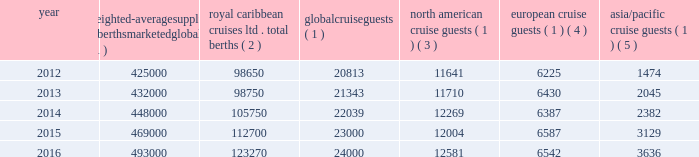The table details the growth in global weighted average berths and the global , north american , european and asia/pacific cruise guests over the past five years ( in thousands , except berth data ) : weighted- average supply of berths marketed globally ( 1 ) caribbean cruises ltd .
Total berths ( 2 ) global cruise guests ( 1 ) american cruise guests ( 1 ) ( 3 ) european cruise guests ( 1 ) ( 4 ) asia/pacific cruise guests ( 1 ) ( 5 ) .
_______________________________________________________________________________ ( 1 ) source : our estimates of the number of global cruise guests and the weighted-average supply of berths marketed globally are based on a combination of data that we obtain from various publicly available cruise industry trade information sources .
We use data obtained from seatrade insider , cruise industry news and company press releases to estimate weighted-average supply of berths and clia and g.p .
Wild to estimate cruise guest information .
In addition , our estimates incorporate our own statistical analysis utilizing the same publicly available cruise industry data as a base .
( 2 ) total berths include our berths related to our global brands and partner brands .
( 3 ) our estimates include the united states and canada .
( 4 ) our estimates include european countries relevant to the industry ( e.g. , nordics , germany , france , italy , spain and the united kingdom ) .
( 5 ) our estimates include the southeast asia ( e.g. , singapore , thailand and the philippines ) , east asia ( e.g. , china and japan ) , south asia ( e.g. , india and pakistan ) and oceanian ( e.g. , australia and fiji islands ) regions .
North america the majority of industry cruise guests are sourced from north america , which represented approximately 52% ( 52 % ) of global cruise guests in 2016 .
The compound annual growth rate in cruise guests sourced from this market was approximately 2% ( 2 % ) from 2012 to 2016 .
Europe industry cruise guests sourced from europe represented approximately 27% ( 27 % ) of global cruise guests in 2016 .
The compound annual growth rate in cruise guests sourced from this market was approximately 1% ( 1 % ) from 2012 to 2016 .
Asia/pacific industry cruise guests sourced from the asia/pacific region represented approximately 15% ( 15 % ) of global cruise guests in 2016 .
The compound annual growth rate in cruise guests sourced from this market was approximately 25% ( 25 % ) from 2012 to 2016 .
The asia/pacific region is experiencing the highest growth rate of the major regions , although it will continue to represent a relatively small sector compared to north america .
Competition we compete with a number of cruise lines .
Our principal competitors are carnival corporation & plc , which owns , among others , aida cruises , carnival cruise line , costa cruises , cunard line , holland america line , p&o cruises , princess cruises and seabourn ; disney cruise line ; msc cruises ; and norwegian cruise line holdings ltd , which owns norwegian cruise line , oceania cruises and regent seven seas cruises .
Cruise lines compete with .
What percentage of total cruise guests in 2016 were not european? 
Computations: (((24000 - 6542) / 24000) * 100)
Answer: 72.74167. 